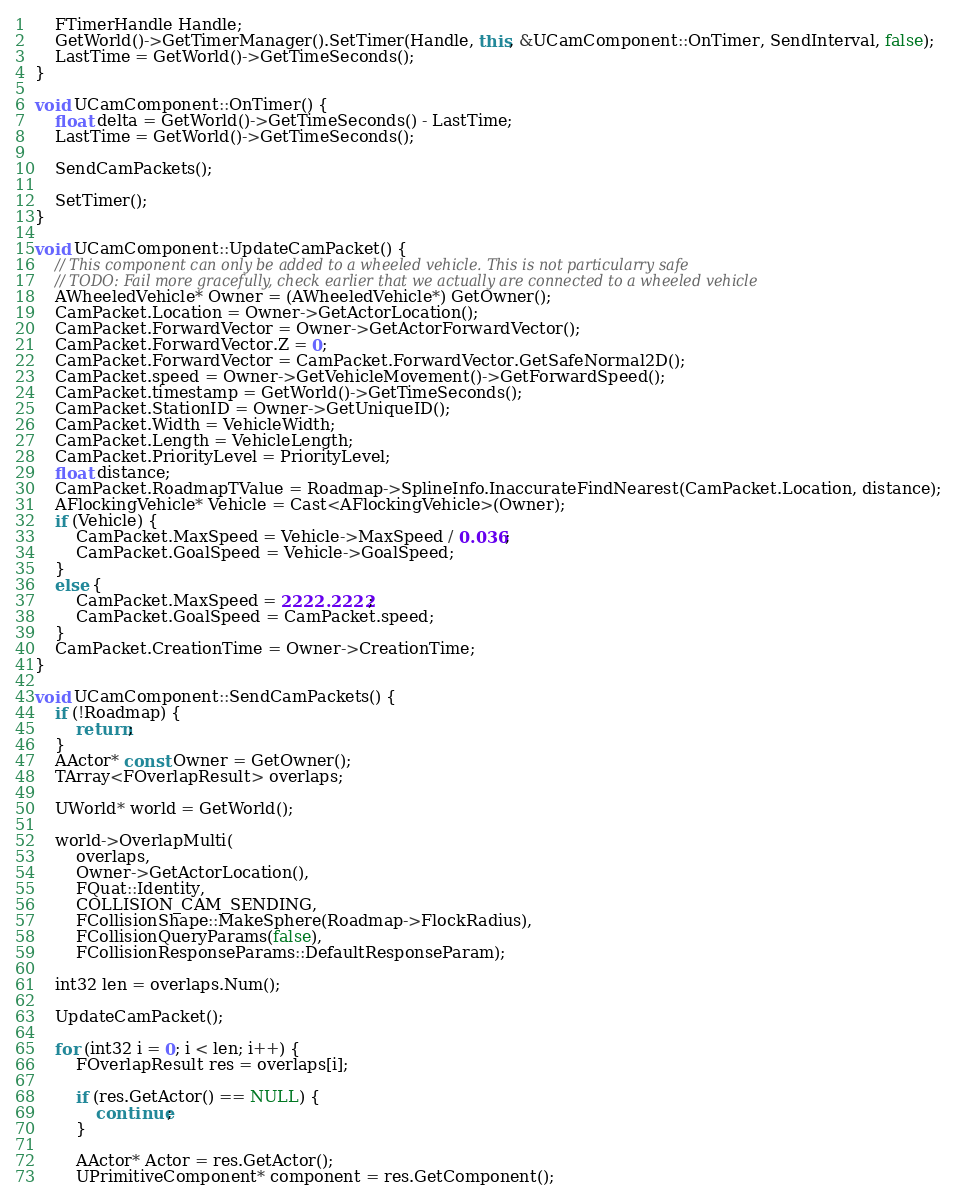<code> <loc_0><loc_0><loc_500><loc_500><_C++_>	FTimerHandle Handle;
	GetWorld()->GetTimerManager().SetTimer(Handle, this, &UCamComponent::OnTimer, SendInterval, false);
	LastTime = GetWorld()->GetTimeSeconds();
}

void UCamComponent::OnTimer() {
	float delta = GetWorld()->GetTimeSeconds() - LastTime;
	LastTime = GetWorld()->GetTimeSeconds();

	SendCamPackets();

	SetTimer();
}

void UCamComponent::UpdateCamPacket() {
	// This component can only be added to a wheeled vehicle. This is not particularry safe
	// TODO: Fail more gracefully, check earlier that we actually are connected to a wheeled vehicle
	AWheeledVehicle* Owner = (AWheeledVehicle*) GetOwner();
	CamPacket.Location = Owner->GetActorLocation();
	CamPacket.ForwardVector = Owner->GetActorForwardVector();
	CamPacket.ForwardVector.Z = 0;
	CamPacket.ForwardVector = CamPacket.ForwardVector.GetSafeNormal2D();
	CamPacket.speed = Owner->GetVehicleMovement()->GetForwardSpeed();
	CamPacket.timestamp = GetWorld()->GetTimeSeconds();
	CamPacket.StationID = Owner->GetUniqueID();
	CamPacket.Width = VehicleWidth;
	CamPacket.Length = VehicleLength;
	CamPacket.PriorityLevel = PriorityLevel;
	float distance;
	CamPacket.RoadmapTValue = Roadmap->SplineInfo.InaccurateFindNearest(CamPacket.Location, distance);
	AFlockingVehicle* Vehicle = Cast<AFlockingVehicle>(Owner);
	if (Vehicle) {
		CamPacket.MaxSpeed = Vehicle->MaxSpeed / 0.036;
		CamPacket.GoalSpeed = Vehicle->GoalSpeed;
	}
	else {
		CamPacket.MaxSpeed = 2222.2222;
		CamPacket.GoalSpeed = CamPacket.speed;
	}
	CamPacket.CreationTime = Owner->CreationTime;
}

void UCamComponent::SendCamPackets() {
	if (!Roadmap) {
		return;
	}
	AActor* const Owner = GetOwner();
	TArray<FOverlapResult> overlaps;

	UWorld* world = GetWorld();

	world->OverlapMulti(
		overlaps,
		Owner->GetActorLocation(),
		FQuat::Identity,
		COLLISION_CAM_SENDING,
		FCollisionShape::MakeSphere(Roadmap->FlockRadius),
		FCollisionQueryParams(false),
		FCollisionResponseParams::DefaultResponseParam);

	int32 len = overlaps.Num();

	UpdateCamPacket();

	for (int32 i = 0; i < len; i++) {
		FOverlapResult res = overlaps[i];

		if (res.GetActor() == NULL) {
			continue;
		}

		AActor* Actor = res.GetActor();
		UPrimitiveComponent* component = res.GetComponent();
</code> 